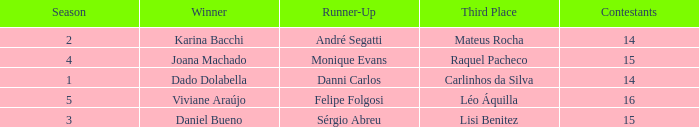How many contestants were there when the runner-up was Monique Evans? 15.0. 